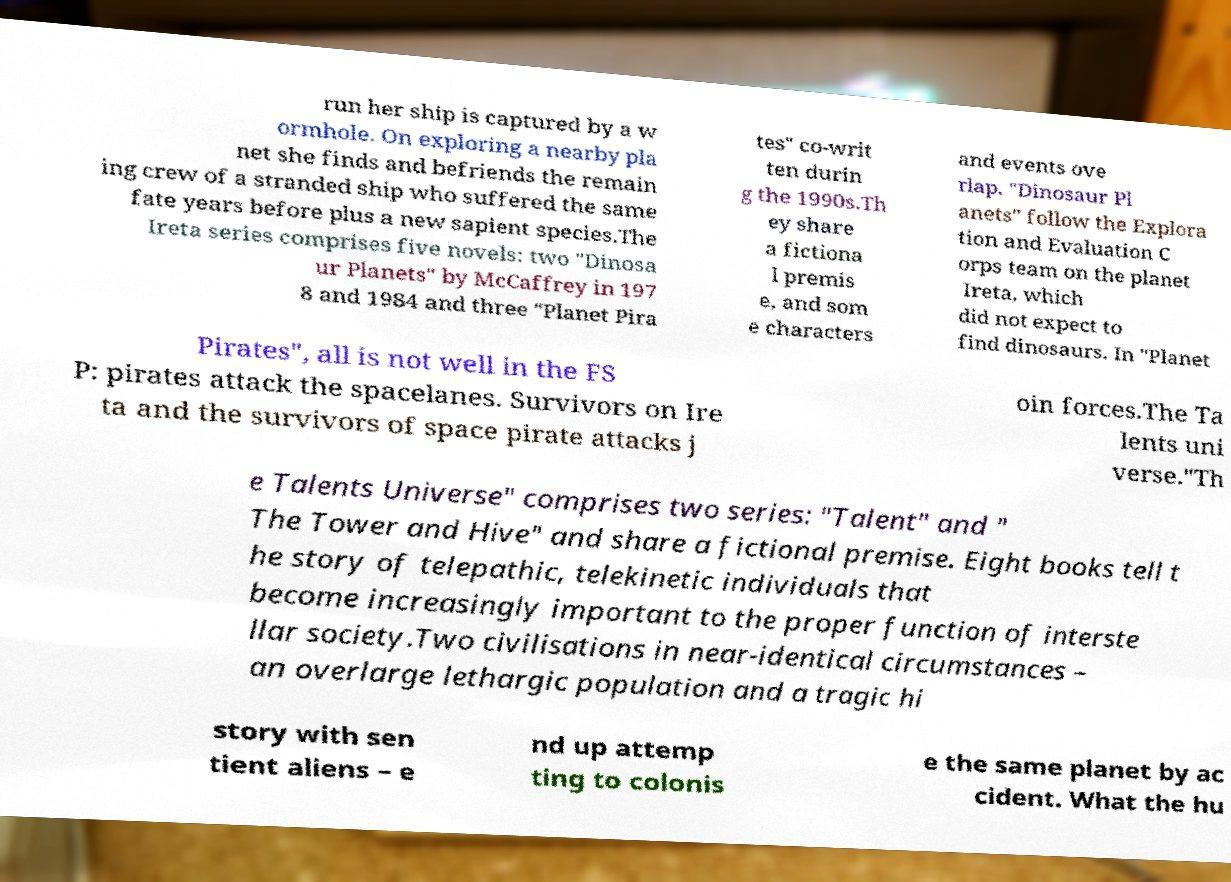I need the written content from this picture converted into text. Can you do that? run her ship is captured by a w ormhole. On exploring a nearby pla net she finds and befriends the remain ing crew of a stranded ship who suffered the same fate years before plus a new sapient species.The Ireta series comprises five novels: two "Dinosa ur Planets" by McCaffrey in 197 8 and 1984 and three "Planet Pira tes" co-writ ten durin g the 1990s.Th ey share a fictiona l premis e, and som e characters and events ove rlap. "Dinosaur Pl anets" follow the Explora tion and Evaluation C orps team on the planet Ireta, which did not expect to find dinosaurs. In "Planet Pirates", all is not well in the FS P: pirates attack the spacelanes. Survivors on Ire ta and the survivors of space pirate attacks j oin forces.The Ta lents uni verse."Th e Talents Universe" comprises two series: "Talent" and " The Tower and Hive" and share a fictional premise. Eight books tell t he story of telepathic, telekinetic individuals that become increasingly important to the proper function of interste llar society.Two civilisations in near-identical circumstances – an overlarge lethargic population and a tragic hi story with sen tient aliens – e nd up attemp ting to colonis e the same planet by ac cident. What the hu 